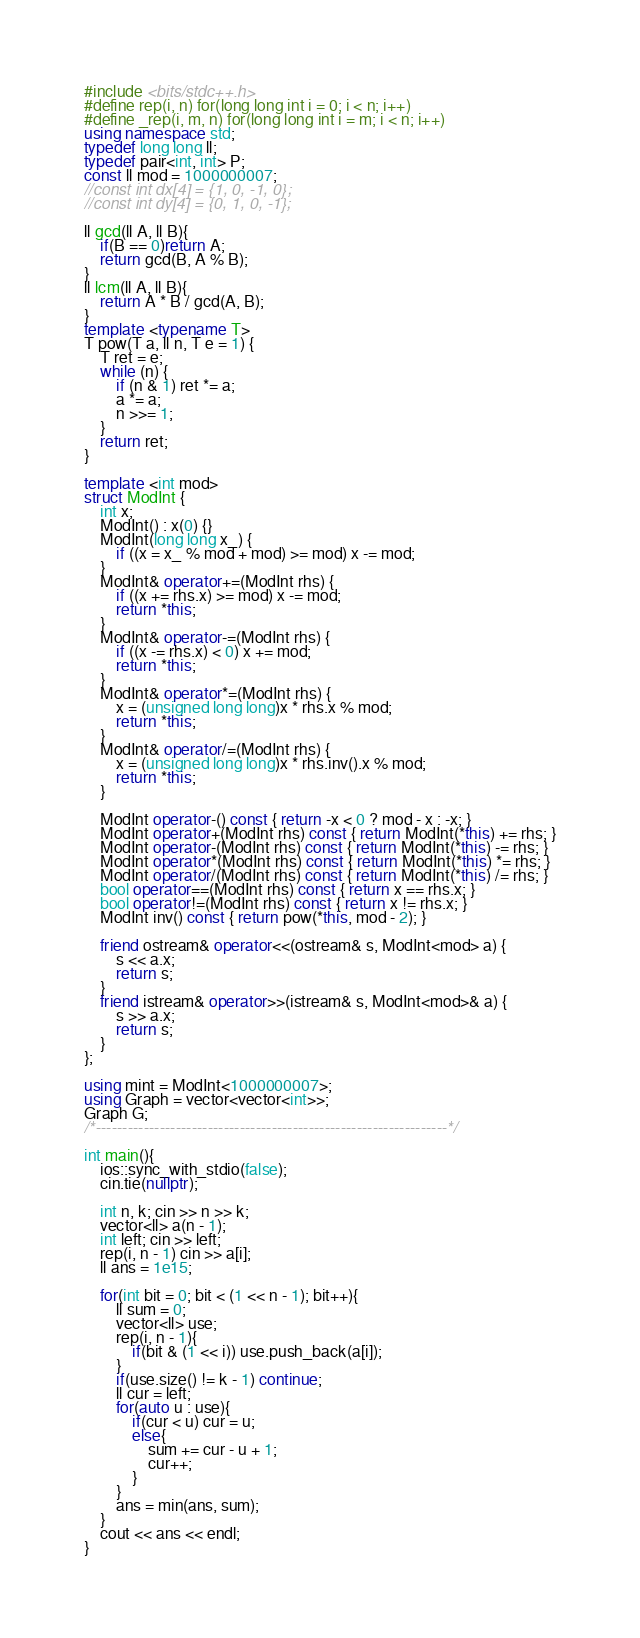Convert code to text. <code><loc_0><loc_0><loc_500><loc_500><_C++_>#include <bits/stdc++.h>   
#define rep(i, n) for(long long int i = 0; i < n; i++)
#define _rep(i, m, n) for(long long int i = m; i < n; i++)
using namespace std;
typedef long long ll;
typedef pair<int, int> P;
const ll mod = 1000000007;
//const int dx[4] = {1, 0, -1, 0};
//const int dy[4] = {0, 1, 0, -1};
     
ll gcd(ll A, ll B){
    if(B == 0)return A;
    return gcd(B, A % B);
}
ll lcm(ll A, ll B){
    return A * B / gcd(A, B);
}
template <typename T>
T pow(T a, ll n, T e = 1) {
    T ret = e;
    while (n) {
        if (n & 1) ret *= a;
        a *= a;
        n >>= 1;
    }
    return ret;
}
 
template <int mod>
struct ModInt {
    int x;
    ModInt() : x(0) {}
    ModInt(long long x_) {
        if ((x = x_ % mod + mod) >= mod) x -= mod;
    }
    ModInt& operator+=(ModInt rhs) {
        if ((x += rhs.x) >= mod) x -= mod;
        return *this;
    }
    ModInt& operator-=(ModInt rhs) {
        if ((x -= rhs.x) < 0) x += mod;
        return *this;
    }
    ModInt& operator*=(ModInt rhs) {
        x = (unsigned long long)x * rhs.x % mod;
        return *this;
    }
    ModInt& operator/=(ModInt rhs) {
        x = (unsigned long long)x * rhs.inv().x % mod;
        return *this;
    }
 
    ModInt operator-() const { return -x < 0 ? mod - x : -x; }
    ModInt operator+(ModInt rhs) const { return ModInt(*this) += rhs; }
    ModInt operator-(ModInt rhs) const { return ModInt(*this) -= rhs; }
    ModInt operator*(ModInt rhs) const { return ModInt(*this) *= rhs; }
    ModInt operator/(ModInt rhs) const { return ModInt(*this) /= rhs; }
    bool operator==(ModInt rhs) const { return x == rhs.x; }
    bool operator!=(ModInt rhs) const { return x != rhs.x; }
    ModInt inv() const { return pow(*this, mod - 2); }
 
    friend ostream& operator<<(ostream& s, ModInt<mod> a) {
        s << a.x;
        return s;
    }
    friend istream& operator>>(istream& s, ModInt<mod>& a) {
        s >> a.x;
        return s;
    }
};
 
using mint = ModInt<1000000007>;
using Graph = vector<vector<int>>;
Graph G;
/*------------------------------------------------------------------*/

int main(){
    ios::sync_with_stdio(false);
    cin.tie(nullptr);

    int n, k; cin >> n >> k;
    vector<ll> a(n - 1);
    int left; cin >> left;
    rep(i, n - 1) cin >> a[i];
    ll ans = 1e15;

    for(int bit = 0; bit < (1 << n - 1); bit++){
        ll sum = 0;
        vector<ll> use;
        rep(i, n - 1){
            if(bit & (1 << i)) use.push_back(a[i]);
        }
        if(use.size() != k - 1) continue;
        ll cur = left;
        for(auto u : use){
            if(cur < u) cur = u;
            else{
                sum += cur - u + 1;
                cur++;
            }
        }
        ans = min(ans, sum);
    }
    cout << ans << endl;
}</code> 